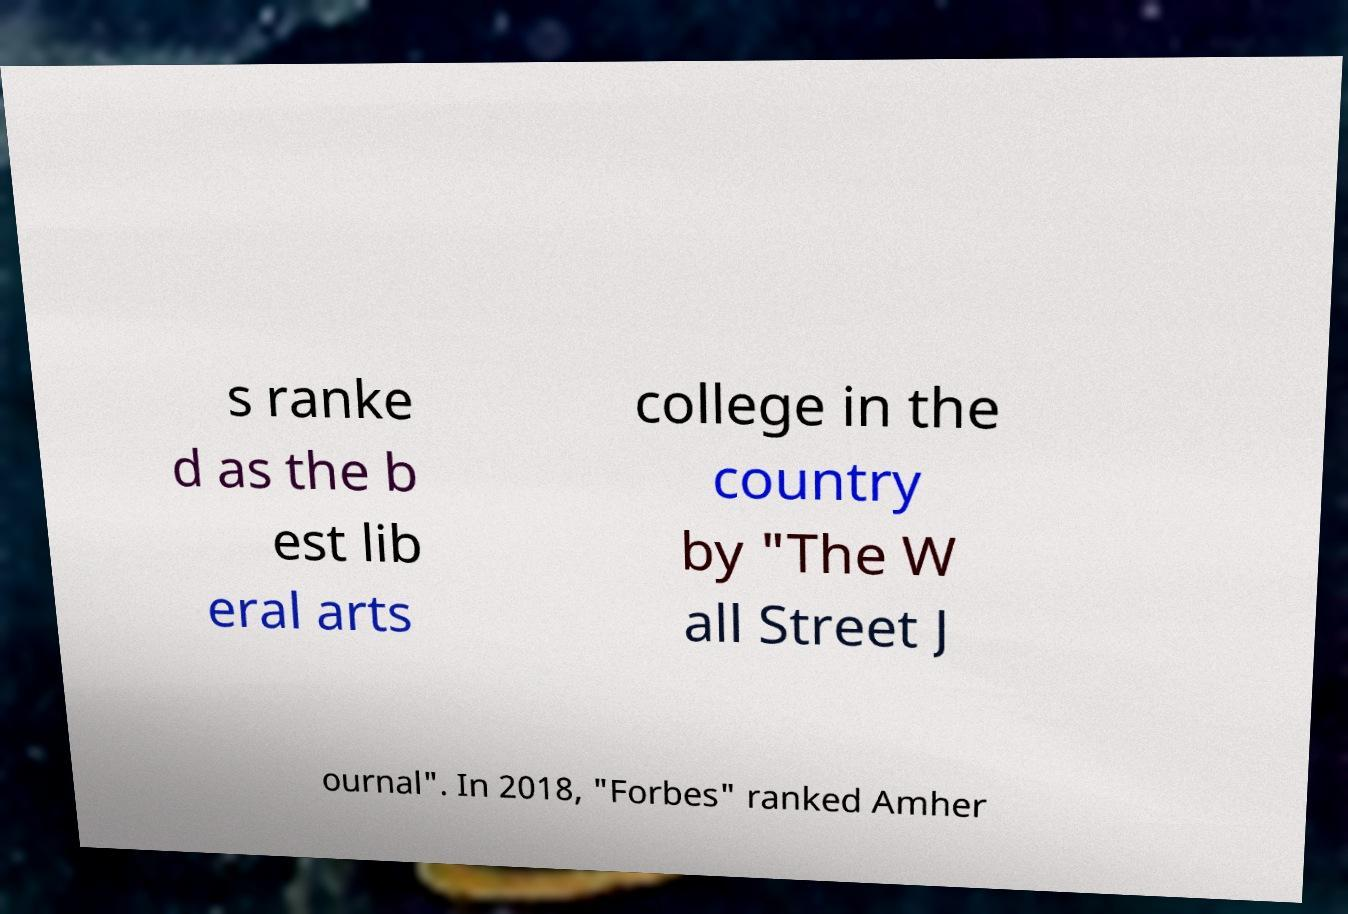Could you extract and type out the text from this image? s ranke d as the b est lib eral arts college in the country by "The W all Street J ournal". In 2018, "Forbes" ranked Amher 